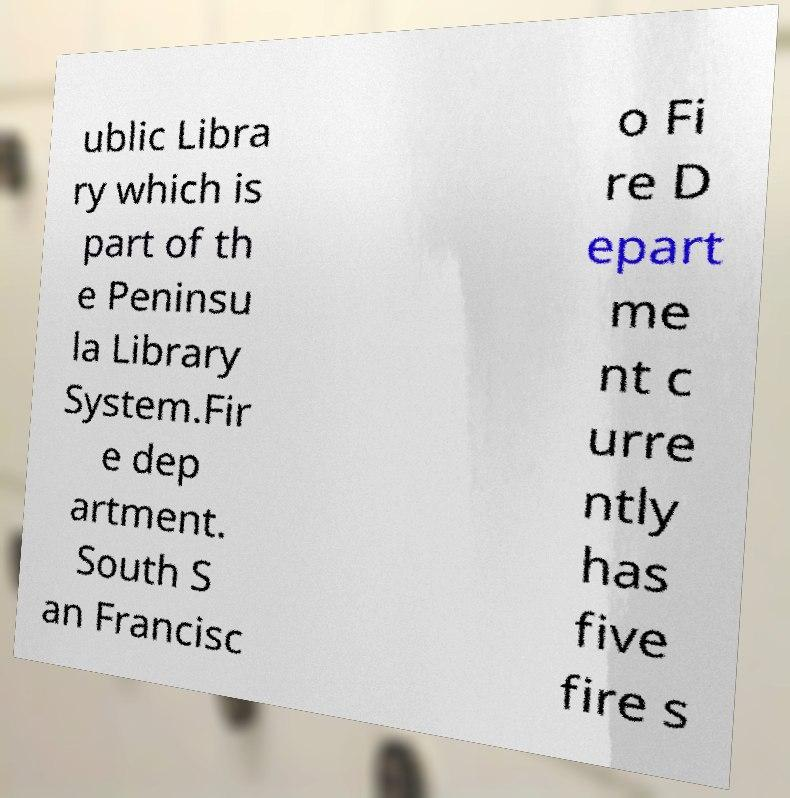Can you accurately transcribe the text from the provided image for me? ublic Libra ry which is part of th e Peninsu la Library System.Fir e dep artment. South S an Francisc o Fi re D epart me nt c urre ntly has five fire s 